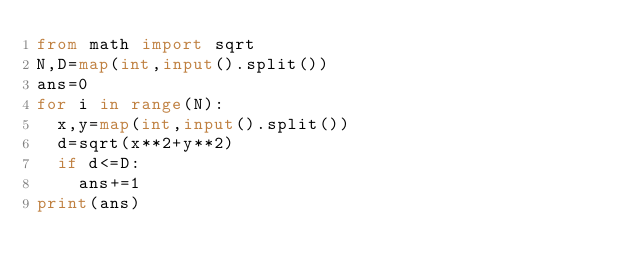Convert code to text. <code><loc_0><loc_0><loc_500><loc_500><_Python_>from math import sqrt
N,D=map(int,input().split())
ans=0
for i in range(N):
  x,y=map(int,input().split())
  d=sqrt(x**2+y**2)
  if d<=D:
    ans+=1
print(ans)</code> 